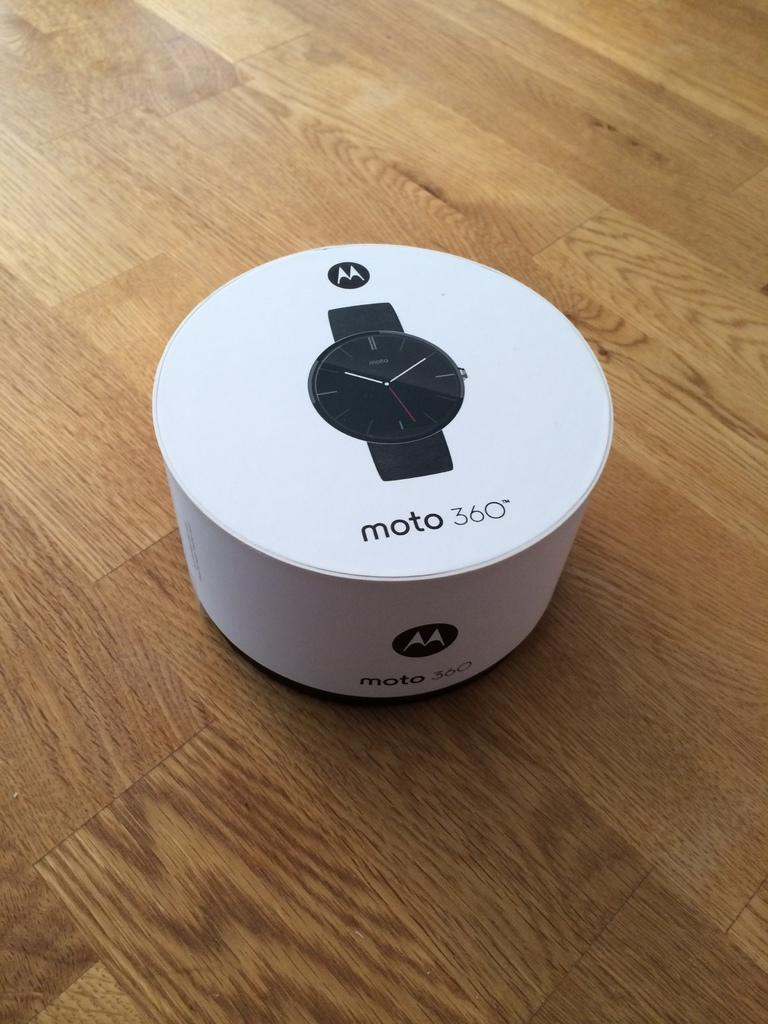<image>
Share a concise interpretation of the image provided. A box with the picture of a Moto 360 smartwatch on it. 